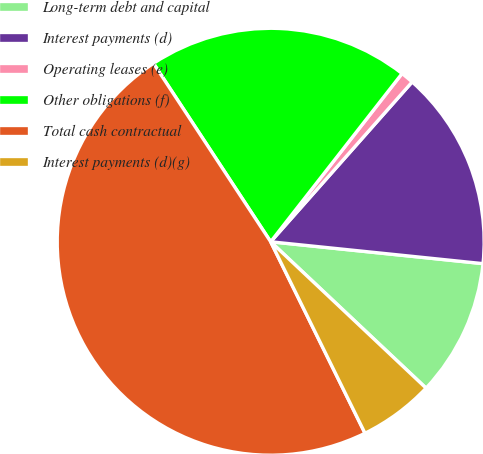Convert chart to OTSL. <chart><loc_0><loc_0><loc_500><loc_500><pie_chart><fcel>Long-term debt and capital<fcel>Interest payments (d)<fcel>Operating leases (e)<fcel>Other obligations (f)<fcel>Total cash contractual<fcel>Interest payments (d)(g)<nl><fcel>10.39%<fcel>15.1%<fcel>0.98%<fcel>19.8%<fcel>48.03%<fcel>5.69%<nl></chart> 